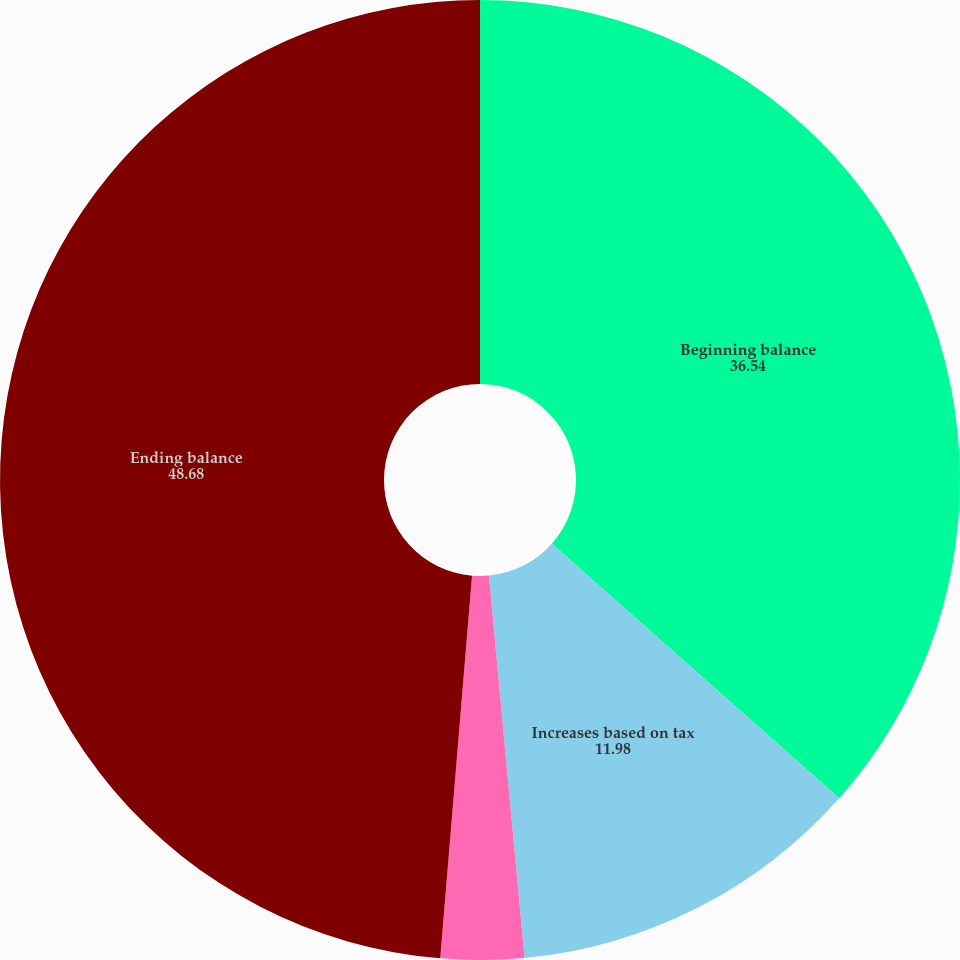Convert chart. <chart><loc_0><loc_0><loc_500><loc_500><pie_chart><fcel>Beginning balance<fcel>Increases based on tax<fcel>Decreases based on tax<fcel>Ending balance<nl><fcel>36.54%<fcel>11.98%<fcel>2.8%<fcel>48.68%<nl></chart> 